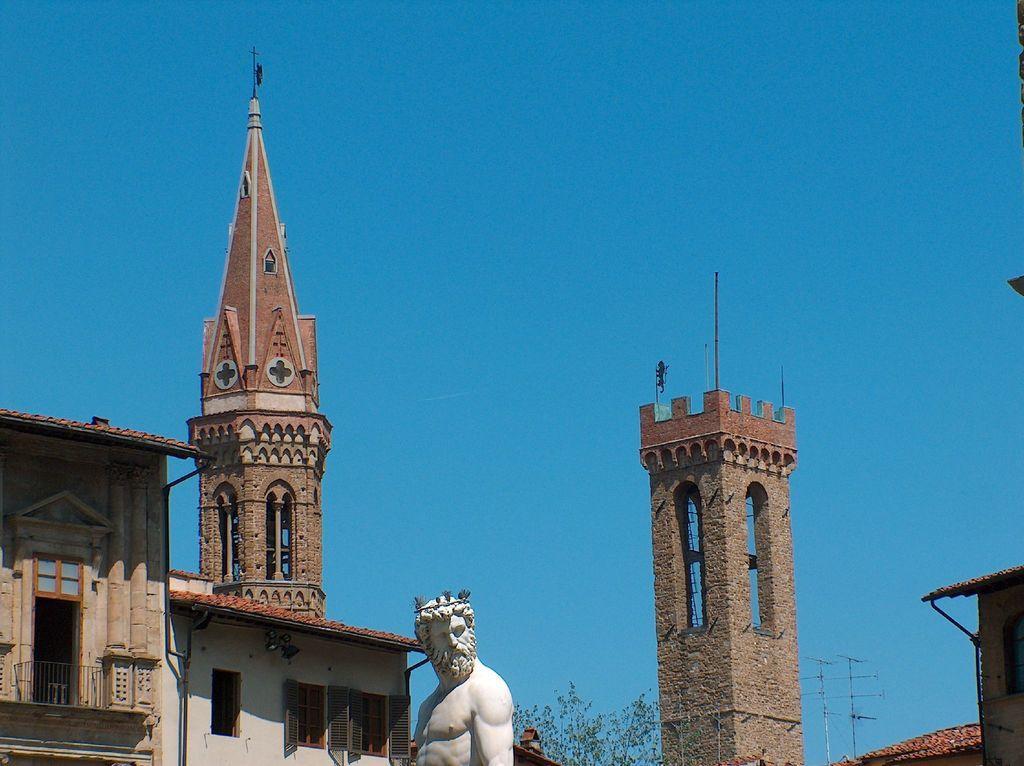Please provide a concise description of this image. In the middle of the image there is a person statue. At the left corner of the image there is a building with walls, door and roof. Beside the building there is another building with windows, walls and roofs. In the background there are towers with brick walls. And also there are trees and electrical pole with wires. At the top of the image there is a sky. 